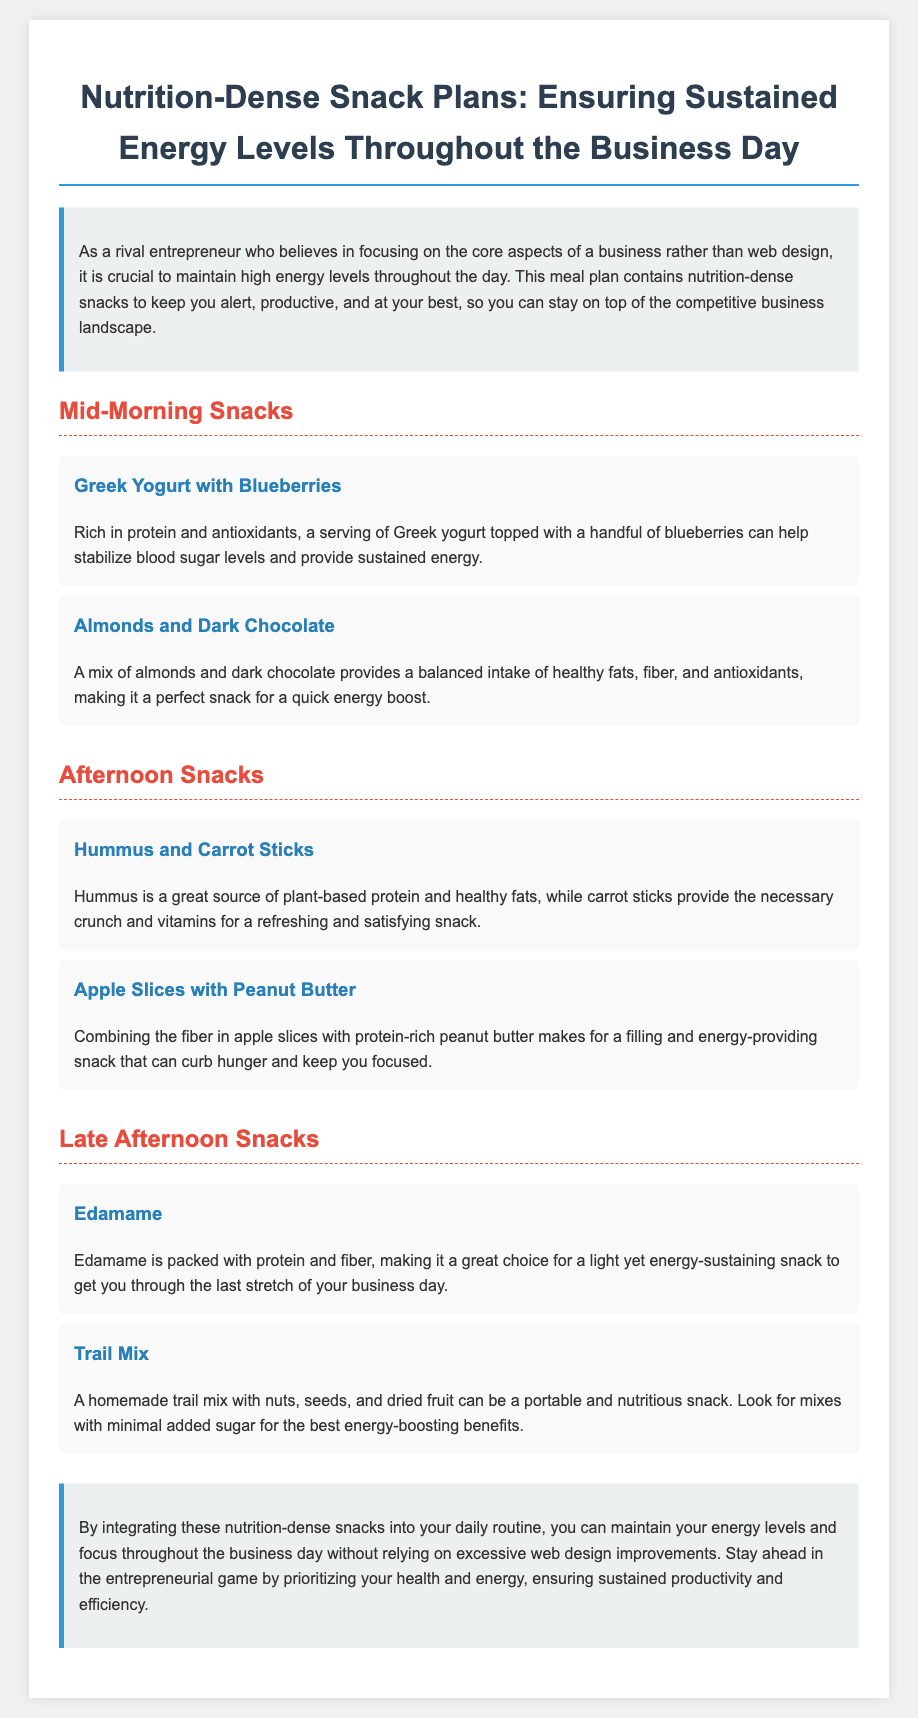What are mid-morning snacks? The document lists mid-morning snacks which include Greek Yogurt with Blueberries and Almonds and Dark Chocolate.
Answer: Greek Yogurt with Blueberries, Almonds and Dark Chocolate How does Greek Yogurt with Blueberries help? It helps stabilize blood sugar levels and provides sustained energy due to its rich protein and antioxidant content.
Answer: Stabilizes blood sugar levels and provides sustained energy What snack is suggested for the afternoon? The afternoon snacks suggested in the document are Hummus and Carrot Sticks and Apple Slices with Peanut Butter.
Answer: Hummus and Carrot Sticks, Apple Slices with Peanut Butter Which snack is rich in plant-based protein? Hummus, mentioned in the afternoon snack section, is a great source of plant-based protein.
Answer: Hummus What is a recommended late afternoon snack? The document recommends Edamame and Trail Mix as late afternoon snacks.
Answer: Edamame and Trail Mix Why is Trail Mix favored as a snack? It is favored because it is portable and nutritious, especially if it has minimal added sugar.
Answer: Portable and nutritious How many snack sections are in the document? The document contains three snack sections: Mid-Morning, Afternoon, and Late Afternoon.
Answer: Three What is the primary goal of the snack plan? The primary goal is to maintain high energy levels throughout the day in a competitive business environment.
Answer: Maintain high energy levels throughout the day What type of snacks does the meal plan emphasize? The meal plan emphasizes nutrition-dense snacks for sustained energy.
Answer: Nutrition-dense snacks 